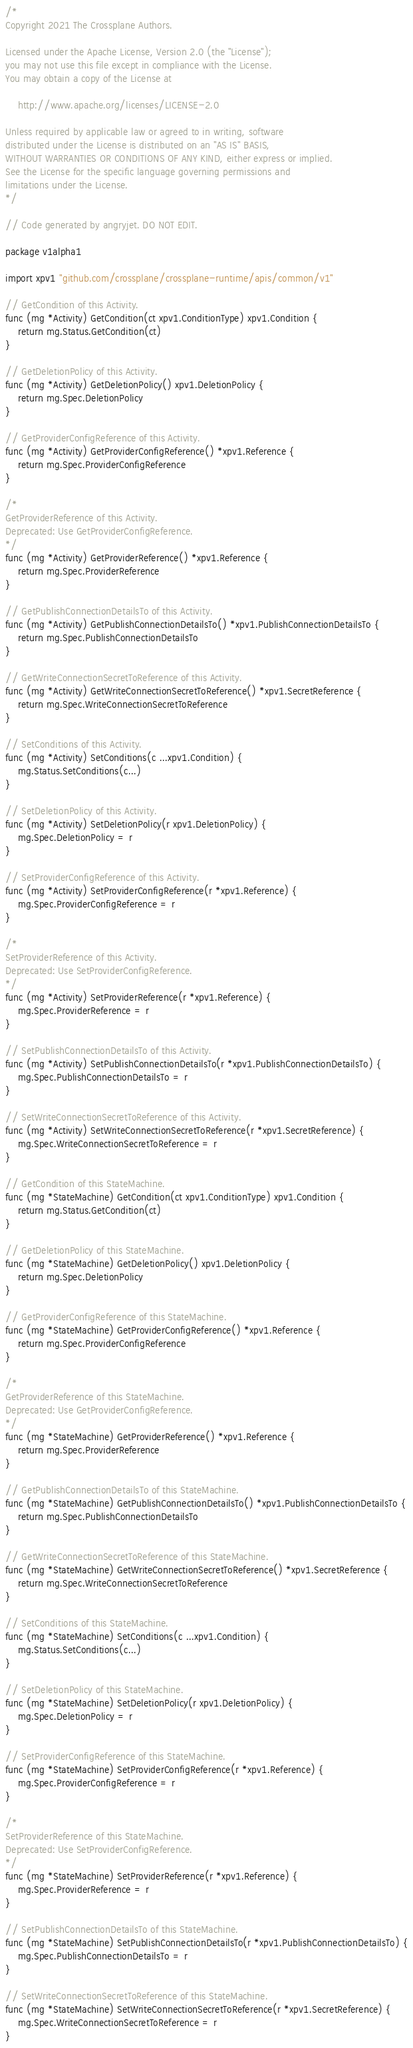Convert code to text. <code><loc_0><loc_0><loc_500><loc_500><_Go_>/*
Copyright 2021 The Crossplane Authors.

Licensed under the Apache License, Version 2.0 (the "License");
you may not use this file except in compliance with the License.
You may obtain a copy of the License at

    http://www.apache.org/licenses/LICENSE-2.0

Unless required by applicable law or agreed to in writing, software
distributed under the License is distributed on an "AS IS" BASIS,
WITHOUT WARRANTIES OR CONDITIONS OF ANY KIND, either express or implied.
See the License for the specific language governing permissions and
limitations under the License.
*/

// Code generated by angryjet. DO NOT EDIT.

package v1alpha1

import xpv1 "github.com/crossplane/crossplane-runtime/apis/common/v1"

// GetCondition of this Activity.
func (mg *Activity) GetCondition(ct xpv1.ConditionType) xpv1.Condition {
	return mg.Status.GetCondition(ct)
}

// GetDeletionPolicy of this Activity.
func (mg *Activity) GetDeletionPolicy() xpv1.DeletionPolicy {
	return mg.Spec.DeletionPolicy
}

// GetProviderConfigReference of this Activity.
func (mg *Activity) GetProviderConfigReference() *xpv1.Reference {
	return mg.Spec.ProviderConfigReference
}

/*
GetProviderReference of this Activity.
Deprecated: Use GetProviderConfigReference.
*/
func (mg *Activity) GetProviderReference() *xpv1.Reference {
	return mg.Spec.ProviderReference
}

// GetPublishConnectionDetailsTo of this Activity.
func (mg *Activity) GetPublishConnectionDetailsTo() *xpv1.PublishConnectionDetailsTo {
	return mg.Spec.PublishConnectionDetailsTo
}

// GetWriteConnectionSecretToReference of this Activity.
func (mg *Activity) GetWriteConnectionSecretToReference() *xpv1.SecretReference {
	return mg.Spec.WriteConnectionSecretToReference
}

// SetConditions of this Activity.
func (mg *Activity) SetConditions(c ...xpv1.Condition) {
	mg.Status.SetConditions(c...)
}

// SetDeletionPolicy of this Activity.
func (mg *Activity) SetDeletionPolicy(r xpv1.DeletionPolicy) {
	mg.Spec.DeletionPolicy = r
}

// SetProviderConfigReference of this Activity.
func (mg *Activity) SetProviderConfigReference(r *xpv1.Reference) {
	mg.Spec.ProviderConfigReference = r
}

/*
SetProviderReference of this Activity.
Deprecated: Use SetProviderConfigReference.
*/
func (mg *Activity) SetProviderReference(r *xpv1.Reference) {
	mg.Spec.ProviderReference = r
}

// SetPublishConnectionDetailsTo of this Activity.
func (mg *Activity) SetPublishConnectionDetailsTo(r *xpv1.PublishConnectionDetailsTo) {
	mg.Spec.PublishConnectionDetailsTo = r
}

// SetWriteConnectionSecretToReference of this Activity.
func (mg *Activity) SetWriteConnectionSecretToReference(r *xpv1.SecretReference) {
	mg.Spec.WriteConnectionSecretToReference = r
}

// GetCondition of this StateMachine.
func (mg *StateMachine) GetCondition(ct xpv1.ConditionType) xpv1.Condition {
	return mg.Status.GetCondition(ct)
}

// GetDeletionPolicy of this StateMachine.
func (mg *StateMachine) GetDeletionPolicy() xpv1.DeletionPolicy {
	return mg.Spec.DeletionPolicy
}

// GetProviderConfigReference of this StateMachine.
func (mg *StateMachine) GetProviderConfigReference() *xpv1.Reference {
	return mg.Spec.ProviderConfigReference
}

/*
GetProviderReference of this StateMachine.
Deprecated: Use GetProviderConfigReference.
*/
func (mg *StateMachine) GetProviderReference() *xpv1.Reference {
	return mg.Spec.ProviderReference
}

// GetPublishConnectionDetailsTo of this StateMachine.
func (mg *StateMachine) GetPublishConnectionDetailsTo() *xpv1.PublishConnectionDetailsTo {
	return mg.Spec.PublishConnectionDetailsTo
}

// GetWriteConnectionSecretToReference of this StateMachine.
func (mg *StateMachine) GetWriteConnectionSecretToReference() *xpv1.SecretReference {
	return mg.Spec.WriteConnectionSecretToReference
}

// SetConditions of this StateMachine.
func (mg *StateMachine) SetConditions(c ...xpv1.Condition) {
	mg.Status.SetConditions(c...)
}

// SetDeletionPolicy of this StateMachine.
func (mg *StateMachine) SetDeletionPolicy(r xpv1.DeletionPolicy) {
	mg.Spec.DeletionPolicy = r
}

// SetProviderConfigReference of this StateMachine.
func (mg *StateMachine) SetProviderConfigReference(r *xpv1.Reference) {
	mg.Spec.ProviderConfigReference = r
}

/*
SetProviderReference of this StateMachine.
Deprecated: Use SetProviderConfigReference.
*/
func (mg *StateMachine) SetProviderReference(r *xpv1.Reference) {
	mg.Spec.ProviderReference = r
}

// SetPublishConnectionDetailsTo of this StateMachine.
func (mg *StateMachine) SetPublishConnectionDetailsTo(r *xpv1.PublishConnectionDetailsTo) {
	mg.Spec.PublishConnectionDetailsTo = r
}

// SetWriteConnectionSecretToReference of this StateMachine.
func (mg *StateMachine) SetWriteConnectionSecretToReference(r *xpv1.SecretReference) {
	mg.Spec.WriteConnectionSecretToReference = r
}
</code> 